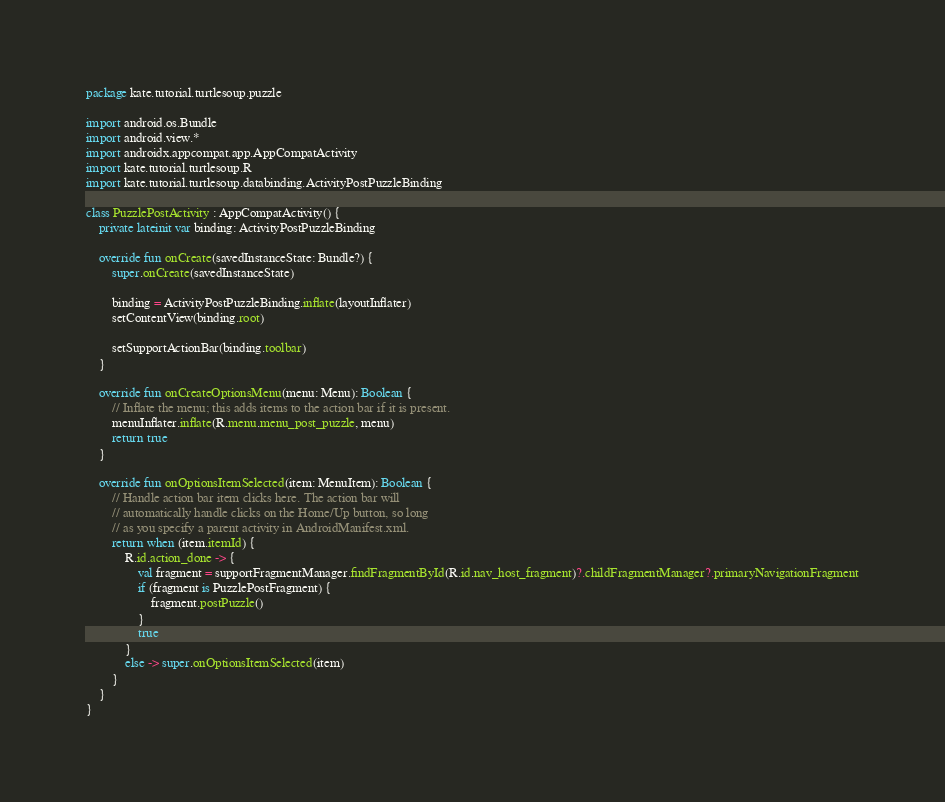<code> <loc_0><loc_0><loc_500><loc_500><_Kotlin_>package kate.tutorial.turtlesoup.puzzle

import android.os.Bundle
import android.view.*
import androidx.appcompat.app.AppCompatActivity
import kate.tutorial.turtlesoup.R
import kate.tutorial.turtlesoup.databinding.ActivityPostPuzzleBinding

class PuzzlePostActivity : AppCompatActivity() {
    private lateinit var binding: ActivityPostPuzzleBinding

    override fun onCreate(savedInstanceState: Bundle?) {
        super.onCreate(savedInstanceState)

        binding = ActivityPostPuzzleBinding.inflate(layoutInflater)
        setContentView(binding.root)

        setSupportActionBar(binding.toolbar)
    }

    override fun onCreateOptionsMenu(menu: Menu): Boolean {
        // Inflate the menu; this adds items to the action bar if it is present.
        menuInflater.inflate(R.menu.menu_post_puzzle, menu)
        return true
    }

    override fun onOptionsItemSelected(item: MenuItem): Boolean {
        // Handle action bar item clicks here. The action bar will
        // automatically handle clicks on the Home/Up button, so long
        // as you specify a parent activity in AndroidManifest.xml.
        return when (item.itemId) {
            R.id.action_done -> {
                val fragment = supportFragmentManager.findFragmentById(R.id.nav_host_fragment)?.childFragmentManager?.primaryNavigationFragment
                if (fragment is PuzzlePostFragment) {
                    fragment.postPuzzle()
                }
                true
            }
            else -> super.onOptionsItemSelected(item)
        }
    }
}
</code> 